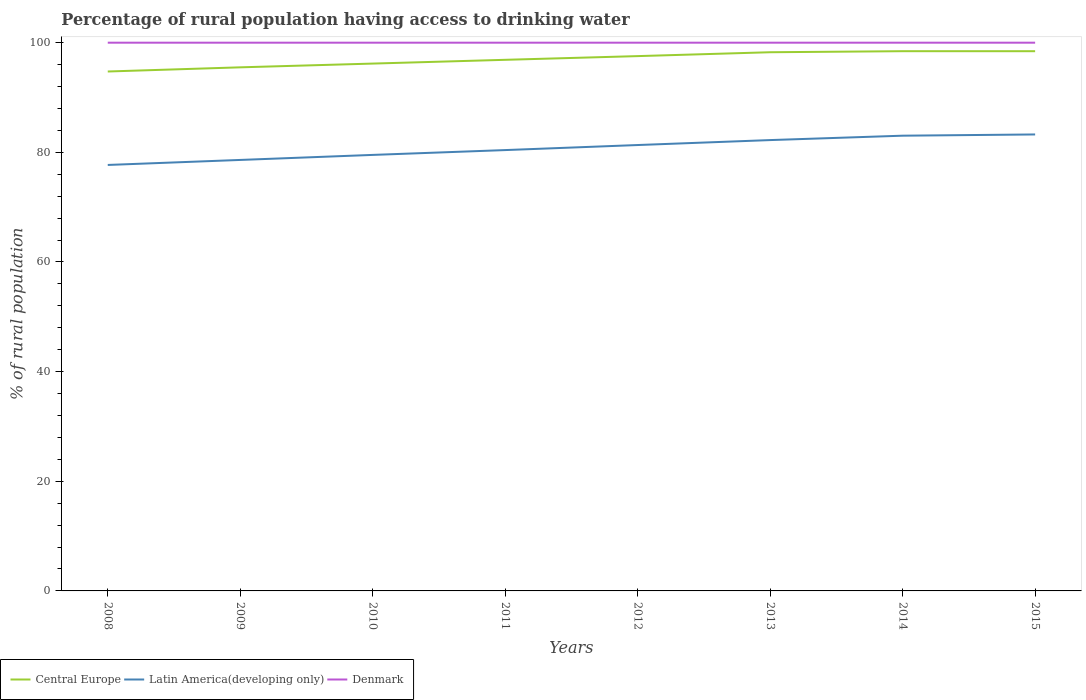How many different coloured lines are there?
Provide a succinct answer. 3. Does the line corresponding to Latin America(developing only) intersect with the line corresponding to Central Europe?
Ensure brevity in your answer.  No. Is the number of lines equal to the number of legend labels?
Make the answer very short. Yes. Across all years, what is the maximum percentage of rural population having access to drinking water in Latin America(developing only)?
Your answer should be very brief. 77.7. In which year was the percentage of rural population having access to drinking water in Central Europe maximum?
Your answer should be very brief. 2008. What is the total percentage of rural population having access to drinking water in Central Europe in the graph?
Offer a terse response. -1.45. What is the difference between the highest and the second highest percentage of rural population having access to drinking water in Latin America(developing only)?
Offer a very short reply. 5.56. What is the difference between the highest and the lowest percentage of rural population having access to drinking water in Latin America(developing only)?
Your response must be concise. 4. Is the percentage of rural population having access to drinking water in Central Europe strictly greater than the percentage of rural population having access to drinking water in Latin America(developing only) over the years?
Make the answer very short. No. How many years are there in the graph?
Your answer should be very brief. 8. Are the values on the major ticks of Y-axis written in scientific E-notation?
Make the answer very short. No. Does the graph contain grids?
Ensure brevity in your answer.  No. How are the legend labels stacked?
Provide a succinct answer. Horizontal. What is the title of the graph?
Offer a terse response. Percentage of rural population having access to drinking water. What is the label or title of the X-axis?
Your response must be concise. Years. What is the label or title of the Y-axis?
Your answer should be very brief. % of rural population. What is the % of rural population in Central Europe in 2008?
Your answer should be very brief. 94.74. What is the % of rural population of Latin America(developing only) in 2008?
Ensure brevity in your answer.  77.7. What is the % of rural population in Denmark in 2008?
Your response must be concise. 100. What is the % of rural population of Central Europe in 2009?
Offer a terse response. 95.51. What is the % of rural population of Latin America(developing only) in 2009?
Your answer should be compact. 78.61. What is the % of rural population in Central Europe in 2010?
Offer a terse response. 96.19. What is the % of rural population in Latin America(developing only) in 2010?
Offer a very short reply. 79.53. What is the % of rural population in Denmark in 2010?
Ensure brevity in your answer.  100. What is the % of rural population in Central Europe in 2011?
Offer a terse response. 96.88. What is the % of rural population in Latin America(developing only) in 2011?
Give a very brief answer. 80.41. What is the % of rural population of Denmark in 2011?
Make the answer very short. 100. What is the % of rural population in Central Europe in 2012?
Provide a short and direct response. 97.55. What is the % of rural population of Latin America(developing only) in 2012?
Provide a succinct answer. 81.33. What is the % of rural population of Denmark in 2012?
Ensure brevity in your answer.  100. What is the % of rural population of Central Europe in 2013?
Give a very brief answer. 98.26. What is the % of rural population in Latin America(developing only) in 2013?
Provide a succinct answer. 82.23. What is the % of rural population of Denmark in 2013?
Your response must be concise. 100. What is the % of rural population in Central Europe in 2014?
Make the answer very short. 98.45. What is the % of rural population in Latin America(developing only) in 2014?
Give a very brief answer. 83.04. What is the % of rural population in Denmark in 2014?
Provide a succinct answer. 100. What is the % of rural population of Central Europe in 2015?
Offer a terse response. 98.45. What is the % of rural population in Latin America(developing only) in 2015?
Your answer should be very brief. 83.26. Across all years, what is the maximum % of rural population of Central Europe?
Keep it short and to the point. 98.45. Across all years, what is the maximum % of rural population in Latin America(developing only)?
Give a very brief answer. 83.26. Across all years, what is the minimum % of rural population in Central Europe?
Offer a very short reply. 94.74. Across all years, what is the minimum % of rural population in Latin America(developing only)?
Ensure brevity in your answer.  77.7. Across all years, what is the minimum % of rural population in Denmark?
Give a very brief answer. 100. What is the total % of rural population in Central Europe in the graph?
Offer a terse response. 776.02. What is the total % of rural population in Latin America(developing only) in the graph?
Give a very brief answer. 646.12. What is the total % of rural population of Denmark in the graph?
Provide a succinct answer. 800. What is the difference between the % of rural population in Central Europe in 2008 and that in 2009?
Ensure brevity in your answer.  -0.76. What is the difference between the % of rural population of Latin America(developing only) in 2008 and that in 2009?
Give a very brief answer. -0.91. What is the difference between the % of rural population of Central Europe in 2008 and that in 2010?
Your response must be concise. -1.45. What is the difference between the % of rural population of Latin America(developing only) in 2008 and that in 2010?
Ensure brevity in your answer.  -1.83. What is the difference between the % of rural population of Denmark in 2008 and that in 2010?
Offer a terse response. 0. What is the difference between the % of rural population in Central Europe in 2008 and that in 2011?
Your answer should be very brief. -2.13. What is the difference between the % of rural population in Latin America(developing only) in 2008 and that in 2011?
Ensure brevity in your answer.  -2.71. What is the difference between the % of rural population in Denmark in 2008 and that in 2011?
Make the answer very short. 0. What is the difference between the % of rural population in Central Europe in 2008 and that in 2012?
Your answer should be compact. -2.81. What is the difference between the % of rural population in Latin America(developing only) in 2008 and that in 2012?
Your answer should be very brief. -3.63. What is the difference between the % of rural population of Denmark in 2008 and that in 2012?
Offer a very short reply. 0. What is the difference between the % of rural population of Central Europe in 2008 and that in 2013?
Your response must be concise. -3.52. What is the difference between the % of rural population in Latin America(developing only) in 2008 and that in 2013?
Your answer should be compact. -4.54. What is the difference between the % of rural population of Denmark in 2008 and that in 2013?
Offer a very short reply. 0. What is the difference between the % of rural population of Central Europe in 2008 and that in 2014?
Your answer should be very brief. -3.7. What is the difference between the % of rural population of Latin America(developing only) in 2008 and that in 2014?
Your response must be concise. -5.34. What is the difference between the % of rural population of Denmark in 2008 and that in 2014?
Your answer should be compact. 0. What is the difference between the % of rural population in Central Europe in 2008 and that in 2015?
Ensure brevity in your answer.  -3.7. What is the difference between the % of rural population of Latin America(developing only) in 2008 and that in 2015?
Offer a terse response. -5.56. What is the difference between the % of rural population in Central Europe in 2009 and that in 2010?
Offer a terse response. -0.68. What is the difference between the % of rural population in Latin America(developing only) in 2009 and that in 2010?
Your answer should be compact. -0.92. What is the difference between the % of rural population in Denmark in 2009 and that in 2010?
Give a very brief answer. 0. What is the difference between the % of rural population of Central Europe in 2009 and that in 2011?
Offer a very short reply. -1.37. What is the difference between the % of rural population of Latin America(developing only) in 2009 and that in 2011?
Make the answer very short. -1.8. What is the difference between the % of rural population in Central Europe in 2009 and that in 2012?
Provide a short and direct response. -2.05. What is the difference between the % of rural population in Latin America(developing only) in 2009 and that in 2012?
Offer a very short reply. -2.72. What is the difference between the % of rural population of Central Europe in 2009 and that in 2013?
Provide a succinct answer. -2.75. What is the difference between the % of rural population in Latin America(developing only) in 2009 and that in 2013?
Make the answer very short. -3.62. What is the difference between the % of rural population in Central Europe in 2009 and that in 2014?
Provide a short and direct response. -2.94. What is the difference between the % of rural population of Latin America(developing only) in 2009 and that in 2014?
Offer a very short reply. -4.42. What is the difference between the % of rural population of Central Europe in 2009 and that in 2015?
Your response must be concise. -2.94. What is the difference between the % of rural population in Latin America(developing only) in 2009 and that in 2015?
Offer a very short reply. -4.65. What is the difference between the % of rural population in Central Europe in 2010 and that in 2011?
Provide a succinct answer. -0.69. What is the difference between the % of rural population in Latin America(developing only) in 2010 and that in 2011?
Your answer should be compact. -0.88. What is the difference between the % of rural population in Denmark in 2010 and that in 2011?
Your answer should be very brief. 0. What is the difference between the % of rural population of Central Europe in 2010 and that in 2012?
Provide a succinct answer. -1.36. What is the difference between the % of rural population of Latin America(developing only) in 2010 and that in 2012?
Provide a short and direct response. -1.8. What is the difference between the % of rural population of Denmark in 2010 and that in 2012?
Provide a succinct answer. 0. What is the difference between the % of rural population in Central Europe in 2010 and that in 2013?
Ensure brevity in your answer.  -2.07. What is the difference between the % of rural population in Latin America(developing only) in 2010 and that in 2013?
Provide a succinct answer. -2.7. What is the difference between the % of rural population of Central Europe in 2010 and that in 2014?
Offer a very short reply. -2.26. What is the difference between the % of rural population in Latin America(developing only) in 2010 and that in 2014?
Provide a short and direct response. -3.5. What is the difference between the % of rural population in Denmark in 2010 and that in 2014?
Provide a succinct answer. 0. What is the difference between the % of rural population of Central Europe in 2010 and that in 2015?
Ensure brevity in your answer.  -2.26. What is the difference between the % of rural population of Latin America(developing only) in 2010 and that in 2015?
Your response must be concise. -3.73. What is the difference between the % of rural population of Central Europe in 2011 and that in 2012?
Give a very brief answer. -0.67. What is the difference between the % of rural population of Latin America(developing only) in 2011 and that in 2012?
Ensure brevity in your answer.  -0.92. What is the difference between the % of rural population of Central Europe in 2011 and that in 2013?
Offer a terse response. -1.38. What is the difference between the % of rural population in Latin America(developing only) in 2011 and that in 2013?
Ensure brevity in your answer.  -1.82. What is the difference between the % of rural population in Central Europe in 2011 and that in 2014?
Make the answer very short. -1.57. What is the difference between the % of rural population in Latin America(developing only) in 2011 and that in 2014?
Your answer should be very brief. -2.62. What is the difference between the % of rural population of Denmark in 2011 and that in 2014?
Your answer should be compact. 0. What is the difference between the % of rural population in Central Europe in 2011 and that in 2015?
Keep it short and to the point. -1.57. What is the difference between the % of rural population of Latin America(developing only) in 2011 and that in 2015?
Ensure brevity in your answer.  -2.85. What is the difference between the % of rural population of Central Europe in 2012 and that in 2013?
Ensure brevity in your answer.  -0.71. What is the difference between the % of rural population of Latin America(developing only) in 2012 and that in 2013?
Provide a short and direct response. -0.9. What is the difference between the % of rural population in Central Europe in 2012 and that in 2014?
Provide a short and direct response. -0.9. What is the difference between the % of rural population of Latin America(developing only) in 2012 and that in 2014?
Provide a succinct answer. -1.7. What is the difference between the % of rural population in Central Europe in 2012 and that in 2015?
Your response must be concise. -0.9. What is the difference between the % of rural population in Latin America(developing only) in 2012 and that in 2015?
Keep it short and to the point. -1.93. What is the difference between the % of rural population of Denmark in 2012 and that in 2015?
Your answer should be compact. 0. What is the difference between the % of rural population in Central Europe in 2013 and that in 2014?
Your answer should be compact. -0.19. What is the difference between the % of rural population in Latin America(developing only) in 2013 and that in 2014?
Your answer should be compact. -0.8. What is the difference between the % of rural population of Central Europe in 2013 and that in 2015?
Your answer should be very brief. -0.19. What is the difference between the % of rural population of Latin America(developing only) in 2013 and that in 2015?
Your answer should be very brief. -1.03. What is the difference between the % of rural population of Denmark in 2013 and that in 2015?
Offer a terse response. 0. What is the difference between the % of rural population of Central Europe in 2014 and that in 2015?
Give a very brief answer. 0. What is the difference between the % of rural population in Latin America(developing only) in 2014 and that in 2015?
Your response must be concise. -0.23. What is the difference between the % of rural population in Central Europe in 2008 and the % of rural population in Latin America(developing only) in 2009?
Provide a short and direct response. 16.13. What is the difference between the % of rural population in Central Europe in 2008 and the % of rural population in Denmark in 2009?
Offer a very short reply. -5.26. What is the difference between the % of rural population of Latin America(developing only) in 2008 and the % of rural population of Denmark in 2009?
Offer a very short reply. -22.3. What is the difference between the % of rural population in Central Europe in 2008 and the % of rural population in Latin America(developing only) in 2010?
Make the answer very short. 15.21. What is the difference between the % of rural population of Central Europe in 2008 and the % of rural population of Denmark in 2010?
Ensure brevity in your answer.  -5.26. What is the difference between the % of rural population of Latin America(developing only) in 2008 and the % of rural population of Denmark in 2010?
Keep it short and to the point. -22.3. What is the difference between the % of rural population in Central Europe in 2008 and the % of rural population in Latin America(developing only) in 2011?
Offer a very short reply. 14.33. What is the difference between the % of rural population in Central Europe in 2008 and the % of rural population in Denmark in 2011?
Provide a succinct answer. -5.26. What is the difference between the % of rural population in Latin America(developing only) in 2008 and the % of rural population in Denmark in 2011?
Provide a succinct answer. -22.3. What is the difference between the % of rural population in Central Europe in 2008 and the % of rural population in Latin America(developing only) in 2012?
Offer a very short reply. 13.41. What is the difference between the % of rural population in Central Europe in 2008 and the % of rural population in Denmark in 2012?
Provide a short and direct response. -5.26. What is the difference between the % of rural population of Latin America(developing only) in 2008 and the % of rural population of Denmark in 2012?
Ensure brevity in your answer.  -22.3. What is the difference between the % of rural population of Central Europe in 2008 and the % of rural population of Latin America(developing only) in 2013?
Keep it short and to the point. 12.51. What is the difference between the % of rural population of Central Europe in 2008 and the % of rural population of Denmark in 2013?
Give a very brief answer. -5.26. What is the difference between the % of rural population of Latin America(developing only) in 2008 and the % of rural population of Denmark in 2013?
Ensure brevity in your answer.  -22.3. What is the difference between the % of rural population of Central Europe in 2008 and the % of rural population of Latin America(developing only) in 2014?
Your answer should be compact. 11.71. What is the difference between the % of rural population of Central Europe in 2008 and the % of rural population of Denmark in 2014?
Your response must be concise. -5.26. What is the difference between the % of rural population of Latin America(developing only) in 2008 and the % of rural population of Denmark in 2014?
Your answer should be very brief. -22.3. What is the difference between the % of rural population in Central Europe in 2008 and the % of rural population in Latin America(developing only) in 2015?
Your response must be concise. 11.48. What is the difference between the % of rural population in Central Europe in 2008 and the % of rural population in Denmark in 2015?
Your answer should be very brief. -5.26. What is the difference between the % of rural population of Latin America(developing only) in 2008 and the % of rural population of Denmark in 2015?
Your answer should be very brief. -22.3. What is the difference between the % of rural population in Central Europe in 2009 and the % of rural population in Latin America(developing only) in 2010?
Your answer should be very brief. 15.97. What is the difference between the % of rural population in Central Europe in 2009 and the % of rural population in Denmark in 2010?
Make the answer very short. -4.49. What is the difference between the % of rural population in Latin America(developing only) in 2009 and the % of rural population in Denmark in 2010?
Provide a short and direct response. -21.39. What is the difference between the % of rural population of Central Europe in 2009 and the % of rural population of Latin America(developing only) in 2011?
Ensure brevity in your answer.  15.09. What is the difference between the % of rural population of Central Europe in 2009 and the % of rural population of Denmark in 2011?
Provide a short and direct response. -4.49. What is the difference between the % of rural population of Latin America(developing only) in 2009 and the % of rural population of Denmark in 2011?
Offer a terse response. -21.39. What is the difference between the % of rural population of Central Europe in 2009 and the % of rural population of Latin America(developing only) in 2012?
Offer a terse response. 14.17. What is the difference between the % of rural population of Central Europe in 2009 and the % of rural population of Denmark in 2012?
Keep it short and to the point. -4.49. What is the difference between the % of rural population in Latin America(developing only) in 2009 and the % of rural population in Denmark in 2012?
Your response must be concise. -21.39. What is the difference between the % of rural population in Central Europe in 2009 and the % of rural population in Latin America(developing only) in 2013?
Give a very brief answer. 13.27. What is the difference between the % of rural population of Central Europe in 2009 and the % of rural population of Denmark in 2013?
Your answer should be very brief. -4.49. What is the difference between the % of rural population of Latin America(developing only) in 2009 and the % of rural population of Denmark in 2013?
Offer a terse response. -21.39. What is the difference between the % of rural population of Central Europe in 2009 and the % of rural population of Latin America(developing only) in 2014?
Provide a succinct answer. 12.47. What is the difference between the % of rural population of Central Europe in 2009 and the % of rural population of Denmark in 2014?
Keep it short and to the point. -4.49. What is the difference between the % of rural population of Latin America(developing only) in 2009 and the % of rural population of Denmark in 2014?
Your answer should be very brief. -21.39. What is the difference between the % of rural population of Central Europe in 2009 and the % of rural population of Latin America(developing only) in 2015?
Provide a succinct answer. 12.24. What is the difference between the % of rural population of Central Europe in 2009 and the % of rural population of Denmark in 2015?
Make the answer very short. -4.49. What is the difference between the % of rural population of Latin America(developing only) in 2009 and the % of rural population of Denmark in 2015?
Provide a short and direct response. -21.39. What is the difference between the % of rural population of Central Europe in 2010 and the % of rural population of Latin America(developing only) in 2011?
Ensure brevity in your answer.  15.78. What is the difference between the % of rural population of Central Europe in 2010 and the % of rural population of Denmark in 2011?
Give a very brief answer. -3.81. What is the difference between the % of rural population of Latin America(developing only) in 2010 and the % of rural population of Denmark in 2011?
Keep it short and to the point. -20.47. What is the difference between the % of rural population in Central Europe in 2010 and the % of rural population in Latin America(developing only) in 2012?
Your response must be concise. 14.86. What is the difference between the % of rural population of Central Europe in 2010 and the % of rural population of Denmark in 2012?
Give a very brief answer. -3.81. What is the difference between the % of rural population of Latin America(developing only) in 2010 and the % of rural population of Denmark in 2012?
Provide a short and direct response. -20.47. What is the difference between the % of rural population of Central Europe in 2010 and the % of rural population of Latin America(developing only) in 2013?
Provide a short and direct response. 13.96. What is the difference between the % of rural population in Central Europe in 2010 and the % of rural population in Denmark in 2013?
Make the answer very short. -3.81. What is the difference between the % of rural population in Latin America(developing only) in 2010 and the % of rural population in Denmark in 2013?
Make the answer very short. -20.47. What is the difference between the % of rural population of Central Europe in 2010 and the % of rural population of Latin America(developing only) in 2014?
Your answer should be very brief. 13.15. What is the difference between the % of rural population of Central Europe in 2010 and the % of rural population of Denmark in 2014?
Offer a very short reply. -3.81. What is the difference between the % of rural population of Latin America(developing only) in 2010 and the % of rural population of Denmark in 2014?
Offer a terse response. -20.47. What is the difference between the % of rural population in Central Europe in 2010 and the % of rural population in Latin America(developing only) in 2015?
Ensure brevity in your answer.  12.93. What is the difference between the % of rural population in Central Europe in 2010 and the % of rural population in Denmark in 2015?
Your response must be concise. -3.81. What is the difference between the % of rural population in Latin America(developing only) in 2010 and the % of rural population in Denmark in 2015?
Provide a short and direct response. -20.47. What is the difference between the % of rural population of Central Europe in 2011 and the % of rural population of Latin America(developing only) in 2012?
Your answer should be compact. 15.54. What is the difference between the % of rural population in Central Europe in 2011 and the % of rural population in Denmark in 2012?
Offer a terse response. -3.12. What is the difference between the % of rural population in Latin America(developing only) in 2011 and the % of rural population in Denmark in 2012?
Ensure brevity in your answer.  -19.59. What is the difference between the % of rural population of Central Europe in 2011 and the % of rural population of Latin America(developing only) in 2013?
Offer a very short reply. 14.64. What is the difference between the % of rural population of Central Europe in 2011 and the % of rural population of Denmark in 2013?
Keep it short and to the point. -3.12. What is the difference between the % of rural population of Latin America(developing only) in 2011 and the % of rural population of Denmark in 2013?
Your response must be concise. -19.59. What is the difference between the % of rural population in Central Europe in 2011 and the % of rural population in Latin America(developing only) in 2014?
Make the answer very short. 13.84. What is the difference between the % of rural population of Central Europe in 2011 and the % of rural population of Denmark in 2014?
Offer a terse response. -3.12. What is the difference between the % of rural population in Latin America(developing only) in 2011 and the % of rural population in Denmark in 2014?
Your answer should be compact. -19.59. What is the difference between the % of rural population in Central Europe in 2011 and the % of rural population in Latin America(developing only) in 2015?
Your response must be concise. 13.61. What is the difference between the % of rural population in Central Europe in 2011 and the % of rural population in Denmark in 2015?
Make the answer very short. -3.12. What is the difference between the % of rural population in Latin America(developing only) in 2011 and the % of rural population in Denmark in 2015?
Your response must be concise. -19.59. What is the difference between the % of rural population of Central Europe in 2012 and the % of rural population of Latin America(developing only) in 2013?
Ensure brevity in your answer.  15.32. What is the difference between the % of rural population of Central Europe in 2012 and the % of rural population of Denmark in 2013?
Offer a very short reply. -2.45. What is the difference between the % of rural population in Latin America(developing only) in 2012 and the % of rural population in Denmark in 2013?
Give a very brief answer. -18.67. What is the difference between the % of rural population of Central Europe in 2012 and the % of rural population of Latin America(developing only) in 2014?
Offer a very short reply. 14.52. What is the difference between the % of rural population of Central Europe in 2012 and the % of rural population of Denmark in 2014?
Provide a short and direct response. -2.45. What is the difference between the % of rural population in Latin America(developing only) in 2012 and the % of rural population in Denmark in 2014?
Your response must be concise. -18.67. What is the difference between the % of rural population of Central Europe in 2012 and the % of rural population of Latin America(developing only) in 2015?
Provide a succinct answer. 14.29. What is the difference between the % of rural population in Central Europe in 2012 and the % of rural population in Denmark in 2015?
Your answer should be very brief. -2.45. What is the difference between the % of rural population in Latin America(developing only) in 2012 and the % of rural population in Denmark in 2015?
Offer a terse response. -18.67. What is the difference between the % of rural population of Central Europe in 2013 and the % of rural population of Latin America(developing only) in 2014?
Offer a terse response. 15.22. What is the difference between the % of rural population in Central Europe in 2013 and the % of rural population in Denmark in 2014?
Provide a succinct answer. -1.74. What is the difference between the % of rural population of Latin America(developing only) in 2013 and the % of rural population of Denmark in 2014?
Your response must be concise. -17.77. What is the difference between the % of rural population of Central Europe in 2013 and the % of rural population of Latin America(developing only) in 2015?
Your answer should be compact. 15. What is the difference between the % of rural population of Central Europe in 2013 and the % of rural population of Denmark in 2015?
Keep it short and to the point. -1.74. What is the difference between the % of rural population of Latin America(developing only) in 2013 and the % of rural population of Denmark in 2015?
Offer a very short reply. -17.77. What is the difference between the % of rural population in Central Europe in 2014 and the % of rural population in Latin America(developing only) in 2015?
Your response must be concise. 15.19. What is the difference between the % of rural population of Central Europe in 2014 and the % of rural population of Denmark in 2015?
Provide a succinct answer. -1.55. What is the difference between the % of rural population of Latin America(developing only) in 2014 and the % of rural population of Denmark in 2015?
Your answer should be compact. -16.96. What is the average % of rural population in Central Europe per year?
Keep it short and to the point. 97. What is the average % of rural population in Latin America(developing only) per year?
Keep it short and to the point. 80.76. In the year 2008, what is the difference between the % of rural population of Central Europe and % of rural population of Latin America(developing only)?
Offer a terse response. 17.05. In the year 2008, what is the difference between the % of rural population of Central Europe and % of rural population of Denmark?
Offer a terse response. -5.26. In the year 2008, what is the difference between the % of rural population in Latin America(developing only) and % of rural population in Denmark?
Offer a very short reply. -22.3. In the year 2009, what is the difference between the % of rural population in Central Europe and % of rural population in Latin America(developing only)?
Your answer should be compact. 16.89. In the year 2009, what is the difference between the % of rural population of Central Europe and % of rural population of Denmark?
Ensure brevity in your answer.  -4.49. In the year 2009, what is the difference between the % of rural population of Latin America(developing only) and % of rural population of Denmark?
Offer a terse response. -21.39. In the year 2010, what is the difference between the % of rural population in Central Europe and % of rural population in Latin America(developing only)?
Give a very brief answer. 16.66. In the year 2010, what is the difference between the % of rural population of Central Europe and % of rural population of Denmark?
Your response must be concise. -3.81. In the year 2010, what is the difference between the % of rural population in Latin America(developing only) and % of rural population in Denmark?
Give a very brief answer. -20.47. In the year 2011, what is the difference between the % of rural population of Central Europe and % of rural population of Latin America(developing only)?
Your response must be concise. 16.47. In the year 2011, what is the difference between the % of rural population in Central Europe and % of rural population in Denmark?
Offer a very short reply. -3.12. In the year 2011, what is the difference between the % of rural population of Latin America(developing only) and % of rural population of Denmark?
Make the answer very short. -19.59. In the year 2012, what is the difference between the % of rural population of Central Europe and % of rural population of Latin America(developing only)?
Ensure brevity in your answer.  16.22. In the year 2012, what is the difference between the % of rural population of Central Europe and % of rural population of Denmark?
Your answer should be very brief. -2.45. In the year 2012, what is the difference between the % of rural population in Latin America(developing only) and % of rural population in Denmark?
Your answer should be very brief. -18.67. In the year 2013, what is the difference between the % of rural population of Central Europe and % of rural population of Latin America(developing only)?
Ensure brevity in your answer.  16.02. In the year 2013, what is the difference between the % of rural population in Central Europe and % of rural population in Denmark?
Provide a succinct answer. -1.74. In the year 2013, what is the difference between the % of rural population of Latin America(developing only) and % of rural population of Denmark?
Make the answer very short. -17.77. In the year 2014, what is the difference between the % of rural population of Central Europe and % of rural population of Latin America(developing only)?
Keep it short and to the point. 15.41. In the year 2014, what is the difference between the % of rural population of Central Europe and % of rural population of Denmark?
Ensure brevity in your answer.  -1.55. In the year 2014, what is the difference between the % of rural population of Latin America(developing only) and % of rural population of Denmark?
Offer a terse response. -16.96. In the year 2015, what is the difference between the % of rural population in Central Europe and % of rural population in Latin America(developing only)?
Give a very brief answer. 15.18. In the year 2015, what is the difference between the % of rural population in Central Europe and % of rural population in Denmark?
Provide a succinct answer. -1.55. In the year 2015, what is the difference between the % of rural population in Latin America(developing only) and % of rural population in Denmark?
Your response must be concise. -16.74. What is the ratio of the % of rural population in Latin America(developing only) in 2008 to that in 2009?
Offer a very short reply. 0.99. What is the ratio of the % of rural population in Denmark in 2008 to that in 2009?
Your answer should be very brief. 1. What is the ratio of the % of rural population of Latin America(developing only) in 2008 to that in 2010?
Keep it short and to the point. 0.98. What is the ratio of the % of rural population of Denmark in 2008 to that in 2010?
Your answer should be very brief. 1. What is the ratio of the % of rural population in Latin America(developing only) in 2008 to that in 2011?
Ensure brevity in your answer.  0.97. What is the ratio of the % of rural population in Central Europe in 2008 to that in 2012?
Give a very brief answer. 0.97. What is the ratio of the % of rural population of Latin America(developing only) in 2008 to that in 2012?
Your answer should be compact. 0.96. What is the ratio of the % of rural population of Denmark in 2008 to that in 2012?
Your answer should be very brief. 1. What is the ratio of the % of rural population in Central Europe in 2008 to that in 2013?
Give a very brief answer. 0.96. What is the ratio of the % of rural population of Latin America(developing only) in 2008 to that in 2013?
Ensure brevity in your answer.  0.94. What is the ratio of the % of rural population in Central Europe in 2008 to that in 2014?
Ensure brevity in your answer.  0.96. What is the ratio of the % of rural population of Latin America(developing only) in 2008 to that in 2014?
Provide a short and direct response. 0.94. What is the ratio of the % of rural population of Denmark in 2008 to that in 2014?
Your answer should be compact. 1. What is the ratio of the % of rural population in Central Europe in 2008 to that in 2015?
Offer a terse response. 0.96. What is the ratio of the % of rural population in Latin America(developing only) in 2008 to that in 2015?
Provide a succinct answer. 0.93. What is the ratio of the % of rural population of Latin America(developing only) in 2009 to that in 2010?
Your answer should be very brief. 0.99. What is the ratio of the % of rural population of Denmark in 2009 to that in 2010?
Your response must be concise. 1. What is the ratio of the % of rural population of Central Europe in 2009 to that in 2011?
Give a very brief answer. 0.99. What is the ratio of the % of rural population in Latin America(developing only) in 2009 to that in 2011?
Provide a short and direct response. 0.98. What is the ratio of the % of rural population in Denmark in 2009 to that in 2011?
Make the answer very short. 1. What is the ratio of the % of rural population in Central Europe in 2009 to that in 2012?
Provide a short and direct response. 0.98. What is the ratio of the % of rural population of Latin America(developing only) in 2009 to that in 2012?
Offer a very short reply. 0.97. What is the ratio of the % of rural population in Central Europe in 2009 to that in 2013?
Your answer should be compact. 0.97. What is the ratio of the % of rural population of Latin America(developing only) in 2009 to that in 2013?
Make the answer very short. 0.96. What is the ratio of the % of rural population in Denmark in 2009 to that in 2013?
Your response must be concise. 1. What is the ratio of the % of rural population of Central Europe in 2009 to that in 2014?
Ensure brevity in your answer.  0.97. What is the ratio of the % of rural population of Latin America(developing only) in 2009 to that in 2014?
Make the answer very short. 0.95. What is the ratio of the % of rural population of Central Europe in 2009 to that in 2015?
Make the answer very short. 0.97. What is the ratio of the % of rural population in Latin America(developing only) in 2009 to that in 2015?
Offer a terse response. 0.94. What is the ratio of the % of rural population in Central Europe in 2010 to that in 2011?
Offer a very short reply. 0.99. What is the ratio of the % of rural population in Latin America(developing only) in 2010 to that in 2011?
Your answer should be very brief. 0.99. What is the ratio of the % of rural population in Central Europe in 2010 to that in 2012?
Provide a short and direct response. 0.99. What is the ratio of the % of rural population in Latin America(developing only) in 2010 to that in 2012?
Provide a short and direct response. 0.98. What is the ratio of the % of rural population of Central Europe in 2010 to that in 2013?
Provide a short and direct response. 0.98. What is the ratio of the % of rural population in Latin America(developing only) in 2010 to that in 2013?
Make the answer very short. 0.97. What is the ratio of the % of rural population in Central Europe in 2010 to that in 2014?
Your response must be concise. 0.98. What is the ratio of the % of rural population of Latin America(developing only) in 2010 to that in 2014?
Provide a succinct answer. 0.96. What is the ratio of the % of rural population of Central Europe in 2010 to that in 2015?
Give a very brief answer. 0.98. What is the ratio of the % of rural population in Latin America(developing only) in 2010 to that in 2015?
Keep it short and to the point. 0.96. What is the ratio of the % of rural population of Denmark in 2010 to that in 2015?
Ensure brevity in your answer.  1. What is the ratio of the % of rural population of Central Europe in 2011 to that in 2012?
Your answer should be compact. 0.99. What is the ratio of the % of rural population in Latin America(developing only) in 2011 to that in 2012?
Provide a succinct answer. 0.99. What is the ratio of the % of rural population in Central Europe in 2011 to that in 2013?
Your response must be concise. 0.99. What is the ratio of the % of rural population in Latin America(developing only) in 2011 to that in 2013?
Offer a very short reply. 0.98. What is the ratio of the % of rural population of Denmark in 2011 to that in 2013?
Your response must be concise. 1. What is the ratio of the % of rural population in Central Europe in 2011 to that in 2014?
Provide a short and direct response. 0.98. What is the ratio of the % of rural population of Latin America(developing only) in 2011 to that in 2014?
Keep it short and to the point. 0.97. What is the ratio of the % of rural population in Central Europe in 2011 to that in 2015?
Provide a succinct answer. 0.98. What is the ratio of the % of rural population in Latin America(developing only) in 2011 to that in 2015?
Keep it short and to the point. 0.97. What is the ratio of the % of rural population of Latin America(developing only) in 2012 to that in 2013?
Give a very brief answer. 0.99. What is the ratio of the % of rural population in Denmark in 2012 to that in 2013?
Offer a very short reply. 1. What is the ratio of the % of rural population in Central Europe in 2012 to that in 2014?
Ensure brevity in your answer.  0.99. What is the ratio of the % of rural population of Latin America(developing only) in 2012 to that in 2014?
Your response must be concise. 0.98. What is the ratio of the % of rural population of Central Europe in 2012 to that in 2015?
Provide a short and direct response. 0.99. What is the ratio of the % of rural population in Latin America(developing only) in 2012 to that in 2015?
Your answer should be compact. 0.98. What is the ratio of the % of rural population of Denmark in 2012 to that in 2015?
Your answer should be compact. 1. What is the ratio of the % of rural population of Central Europe in 2013 to that in 2014?
Give a very brief answer. 1. What is the ratio of the % of rural population of Central Europe in 2013 to that in 2015?
Your answer should be compact. 1. What is the ratio of the % of rural population of Latin America(developing only) in 2013 to that in 2015?
Provide a short and direct response. 0.99. What is the difference between the highest and the second highest % of rural population of Central Europe?
Give a very brief answer. 0. What is the difference between the highest and the second highest % of rural population of Latin America(developing only)?
Keep it short and to the point. 0.23. What is the difference between the highest and the lowest % of rural population of Central Europe?
Your answer should be compact. 3.7. What is the difference between the highest and the lowest % of rural population in Latin America(developing only)?
Make the answer very short. 5.56. What is the difference between the highest and the lowest % of rural population of Denmark?
Provide a succinct answer. 0. 